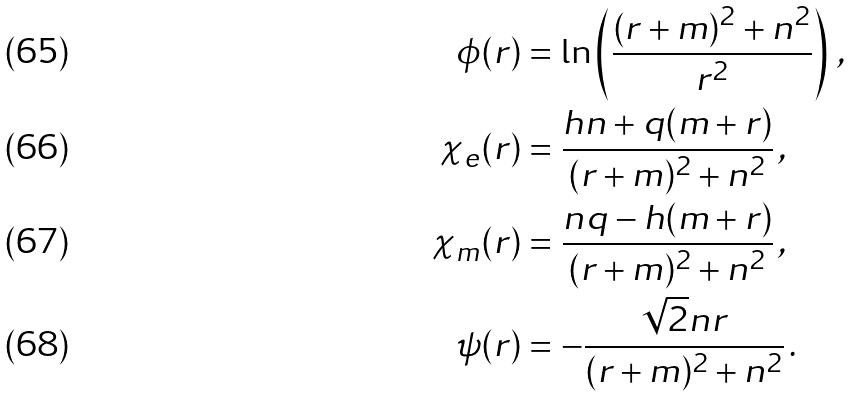<formula> <loc_0><loc_0><loc_500><loc_500>\phi ( r ) & = \ln \left ( \frac { ( r + m ) ^ { 2 } + n ^ { 2 } } { r ^ { 2 } } \right ) \, , \\ \chi _ { e } ( r ) & = \frac { h n + q ( m + r ) } { ( r + m ) ^ { 2 } + n ^ { 2 } } \, , \\ \chi _ { m } ( r ) & = \frac { n q - h ( m + r ) } { ( r + m ) ^ { 2 } + n ^ { 2 } } \, , \\ \psi ( r ) & = - \frac { \sqrt { 2 } n r } { ( r + m ) ^ { 2 } + n ^ { 2 } } \, .</formula> 